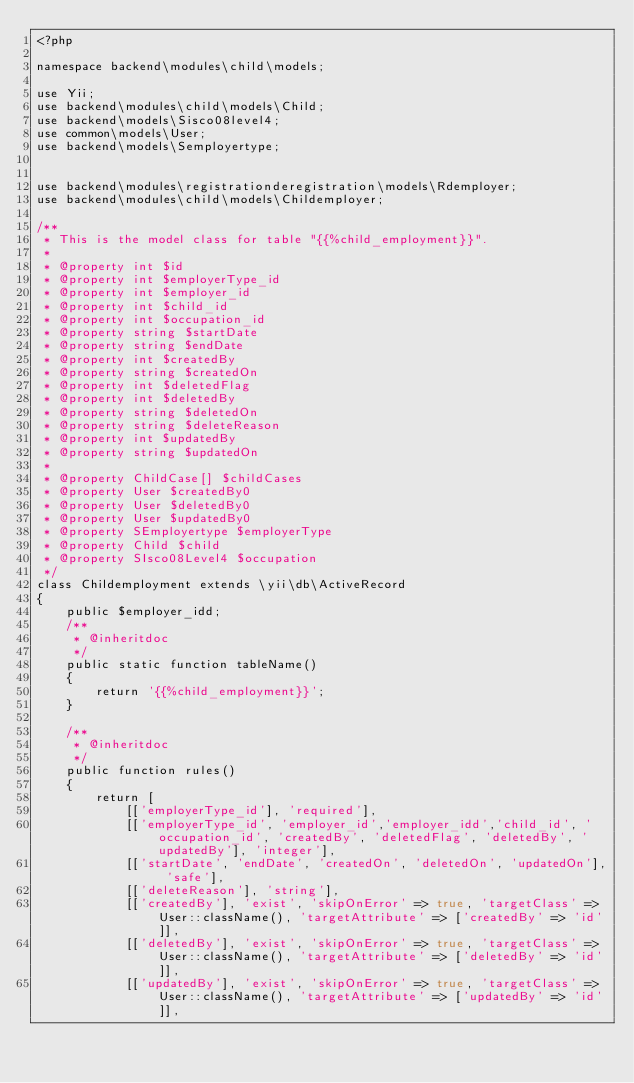Convert code to text. <code><loc_0><loc_0><loc_500><loc_500><_PHP_><?php

namespace backend\modules\child\models;

use Yii;
use backend\modules\child\models\Child;
use backend\models\Sisco08level4;
use common\models\User;
use backend\models\Semployertype;


use backend\modules\registrationderegistration\models\Rdemployer;
use backend\modules\child\models\Childemployer;

/**
 * This is the model class for table "{{%child_employment}}".
 *
 * @property int $id
 * @property int $employerType_id
 * @property int $employer_id
 * @property int $child_id
 * @property int $occupation_id
 * @property string $startDate
 * @property string $endDate
 * @property int $createdBy
 * @property string $createdOn
 * @property int $deletedFlag
 * @property int $deletedBy
 * @property string $deletedOn
 * @property string $deleteReason
 * @property int $updatedBy
 * @property string $updatedOn
 *
 * @property ChildCase[] $childCases
 * @property User $createdBy0
 * @property User $deletedBy0
 * @property User $updatedBy0
 * @property SEmployertype $employerType
 * @property Child $child
 * @property SIsco08Level4 $occupation
 */
class Childemployment extends \yii\db\ActiveRecord
{
    public $employer_idd;
    /**
     * @inheritdoc
     */
    public static function tableName()
    {
        return '{{%child_employment}}';
    }

    /**
     * @inheritdoc
     */
    public function rules()
    {
        return [
            [['employerType_id'], 'required'],
            [['employerType_id', 'employer_id','employer_idd','child_id', 'occupation_id', 'createdBy', 'deletedFlag', 'deletedBy', 'updatedBy'], 'integer'],
            [['startDate', 'endDate', 'createdOn', 'deletedOn', 'updatedOn'], 'safe'],
            [['deleteReason'], 'string'],
            [['createdBy'], 'exist', 'skipOnError' => true, 'targetClass' => User::className(), 'targetAttribute' => ['createdBy' => 'id']],
            [['deletedBy'], 'exist', 'skipOnError' => true, 'targetClass' => User::className(), 'targetAttribute' => ['deletedBy' => 'id']],
            [['updatedBy'], 'exist', 'skipOnError' => true, 'targetClass' => User::className(), 'targetAttribute' => ['updatedBy' => 'id']],</code> 